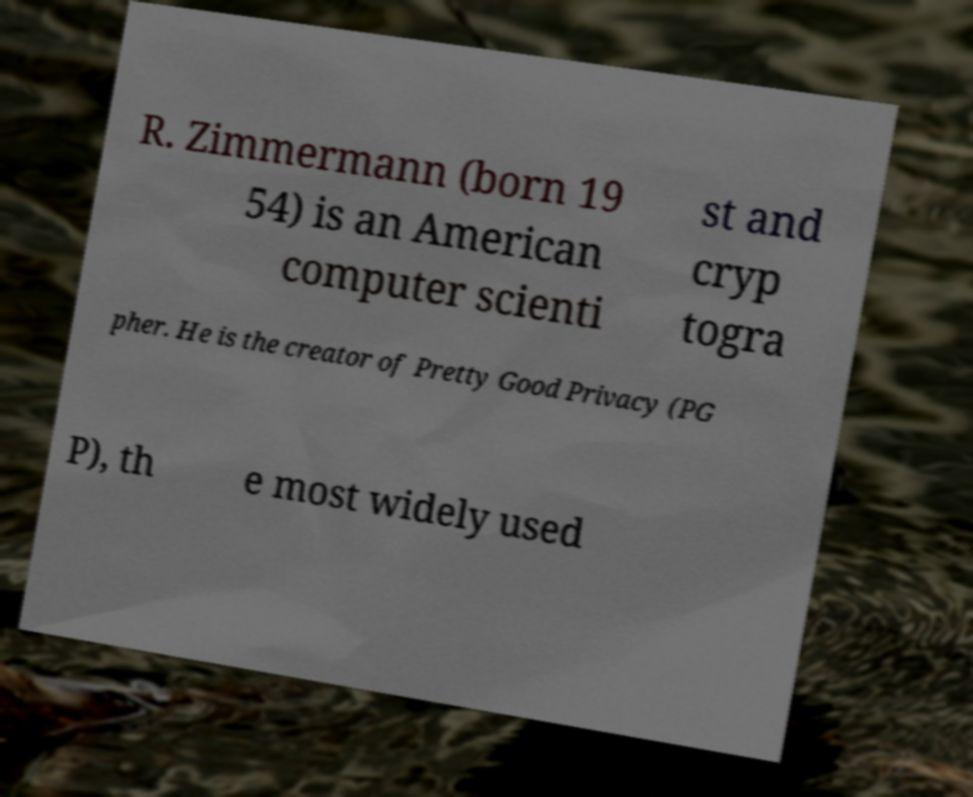Please identify and transcribe the text found in this image. R. Zimmermann (born 19 54) is an American computer scienti st and cryp togra pher. He is the creator of Pretty Good Privacy (PG P), th e most widely used 